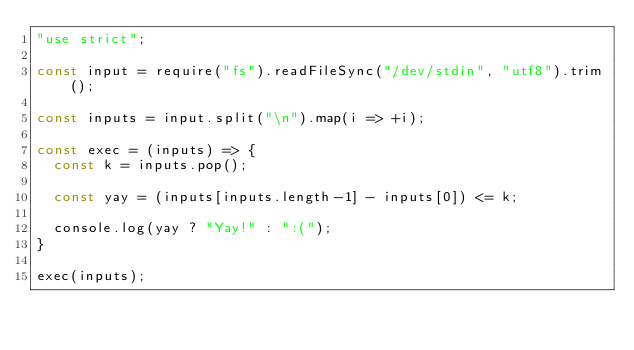<code> <loc_0><loc_0><loc_500><loc_500><_JavaScript_>"use strict";

const input = require("fs").readFileSync("/dev/stdin", "utf8").trim();

const inputs = input.split("\n").map(i => +i);

const exec = (inputs) => {
  const k = inputs.pop();

  const yay = (inputs[inputs.length-1] - inputs[0]) <= k;

  console.log(yay ? "Yay!" : ":(");
}

exec(inputs);
</code> 